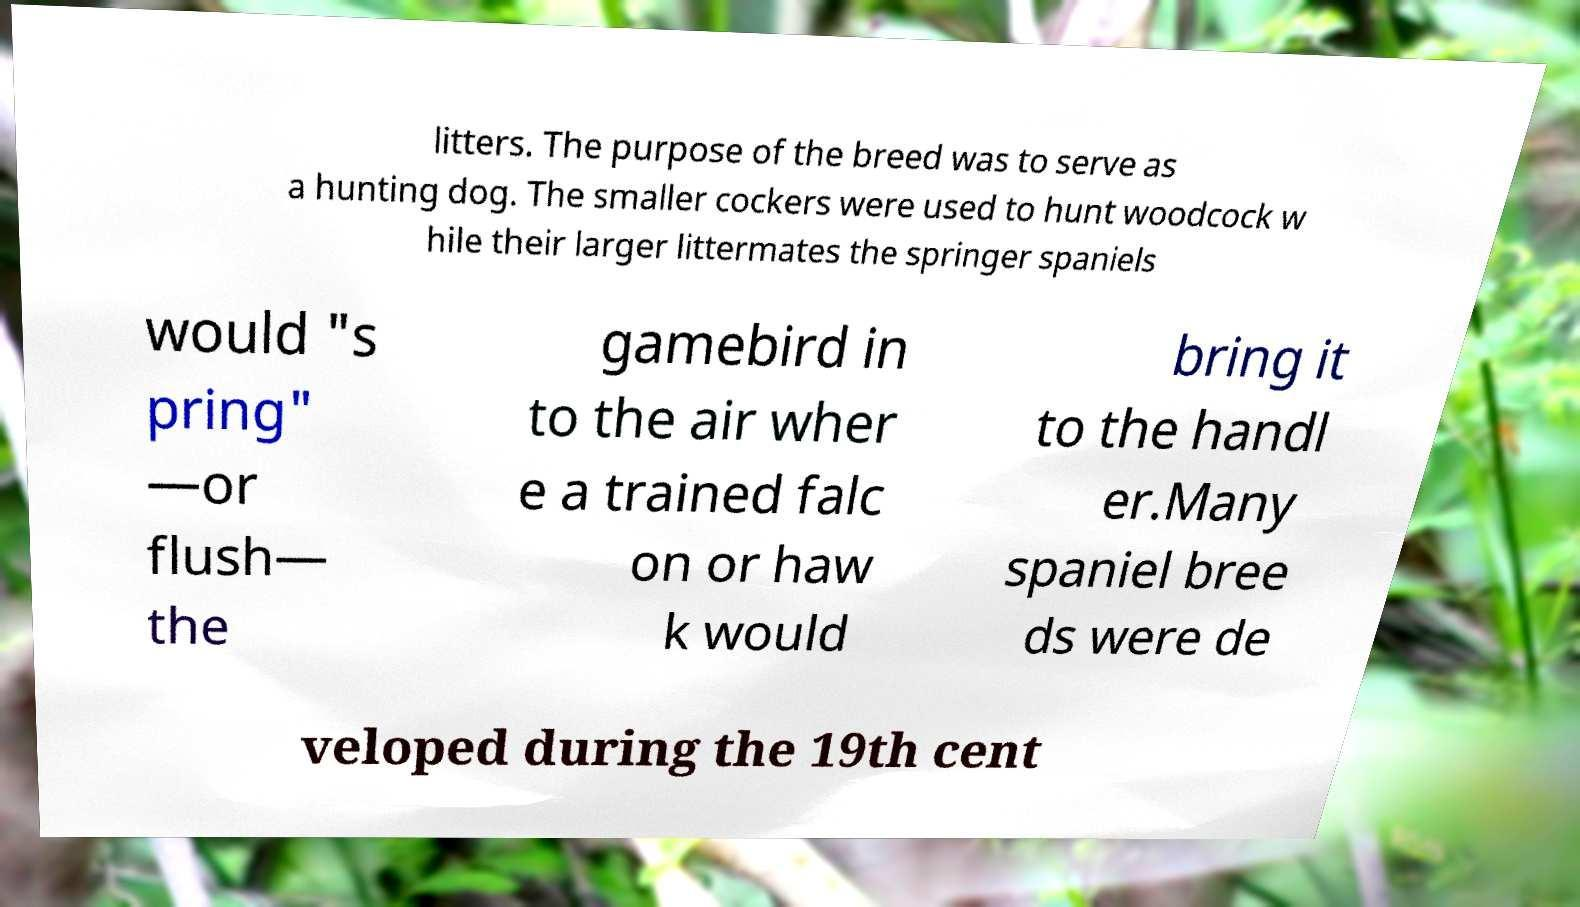Can you accurately transcribe the text from the provided image for me? litters. The purpose of the breed was to serve as a hunting dog. The smaller cockers were used to hunt woodcock w hile their larger littermates the springer spaniels would "s pring" —or flush— the gamebird in to the air wher e a trained falc on or haw k would bring it to the handl er.Many spaniel bree ds were de veloped during the 19th cent 